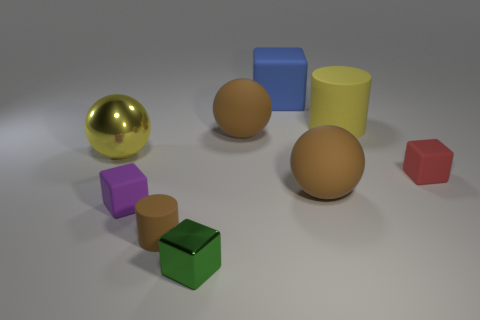Subtract 1 spheres. How many spheres are left? 2 Subtract all purple blocks. How many blocks are left? 3 Add 1 big metal balls. How many objects exist? 10 Subtract all brown cubes. Subtract all red spheres. How many cubes are left? 4 Subtract all purple matte blocks. How many blocks are left? 3 Subtract all cylinders. How many objects are left? 7 Subtract all green cubes. Subtract all blue shiny balls. How many objects are left? 8 Add 4 big rubber things. How many big rubber things are left? 8 Add 3 red rubber things. How many red rubber things exist? 4 Subtract 0 yellow cubes. How many objects are left? 9 